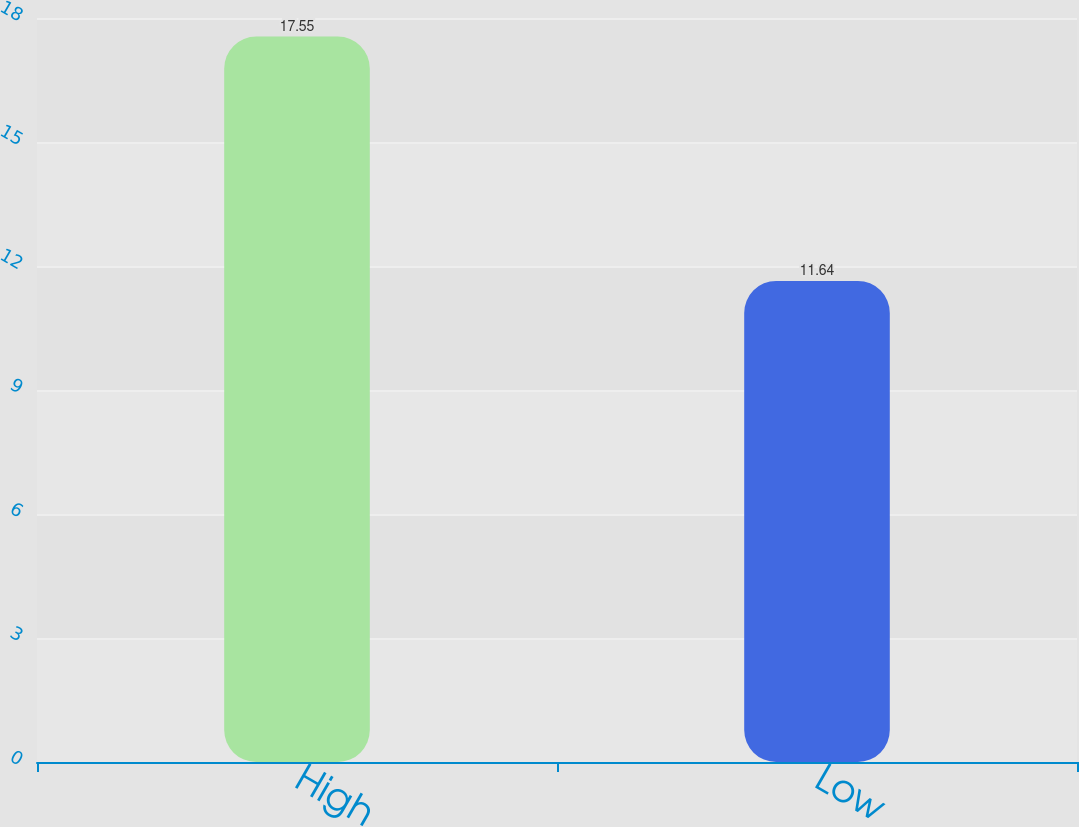Convert chart. <chart><loc_0><loc_0><loc_500><loc_500><bar_chart><fcel>High<fcel>Low<nl><fcel>17.55<fcel>11.64<nl></chart> 